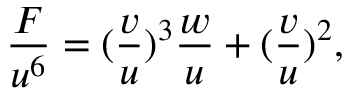<formula> <loc_0><loc_0><loc_500><loc_500>\frac { F } { u ^ { 6 } } = ( \frac { v } { u } ) ^ { 3 } \frac { w } { u } + ( \frac { v } { u } ) ^ { 2 } ,</formula> 